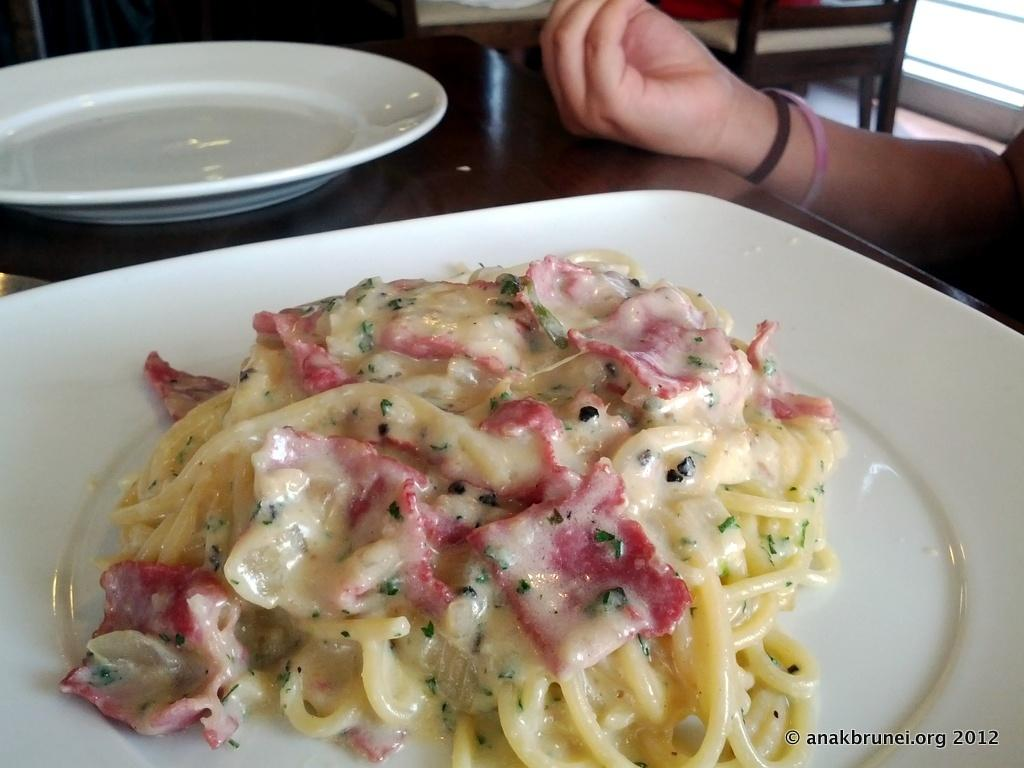What objects are on the table in the image? There are plates and food on the table in the image. Can you describe the person's hand in the image? A person's hand is visible in the image, but no specific details about the hand are provided. What is present at the bottom of the image? There is a watermark at the bottom of the image. What type of crow is sitting on the person's hand in the image? There is no crow present in the image; only a person's hand is visible. How does the wren contribute to the loss in the image? There is no wren or loss present in the image. 